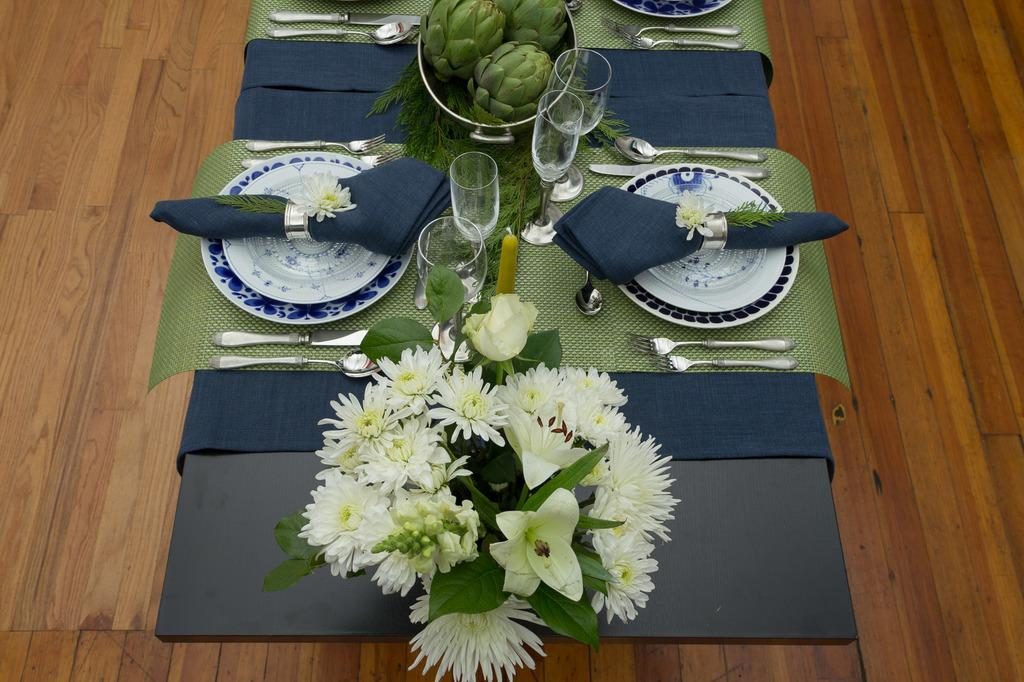What type of tableware can be seen in the image? There are plates, a spoon, knives, and forks visible in the image. What type of dish is present in the image? There is a bowl in the image. What type of decorative item is present in the image? There is a flower vase in the image. What type of glassware is present in the image? There are wine glasses in the image. Where are all these objects located? All of these objects are on a table. What type of cork can be seen in the image? There is no cork present in the image. What type of line is used to draw the objects in the image? The image is a photograph, not a drawing, so there are no lines used to depict the objects. 